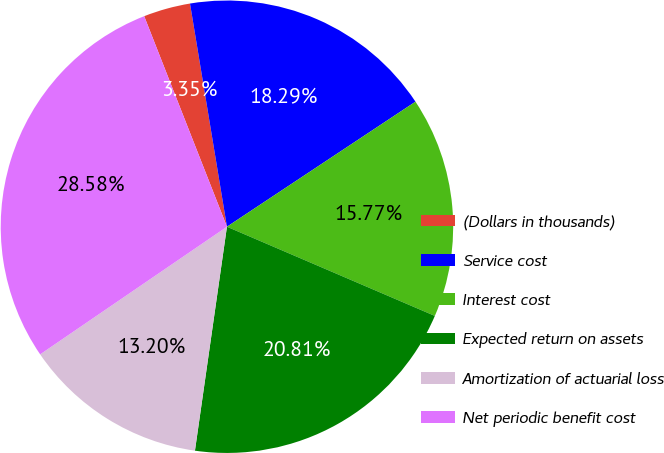<chart> <loc_0><loc_0><loc_500><loc_500><pie_chart><fcel>(Dollars in thousands)<fcel>Service cost<fcel>Interest cost<fcel>Expected return on assets<fcel>Amortization of actuarial loss<fcel>Net periodic benefit cost<nl><fcel>3.35%<fcel>18.29%<fcel>15.77%<fcel>20.81%<fcel>13.2%<fcel>28.58%<nl></chart> 